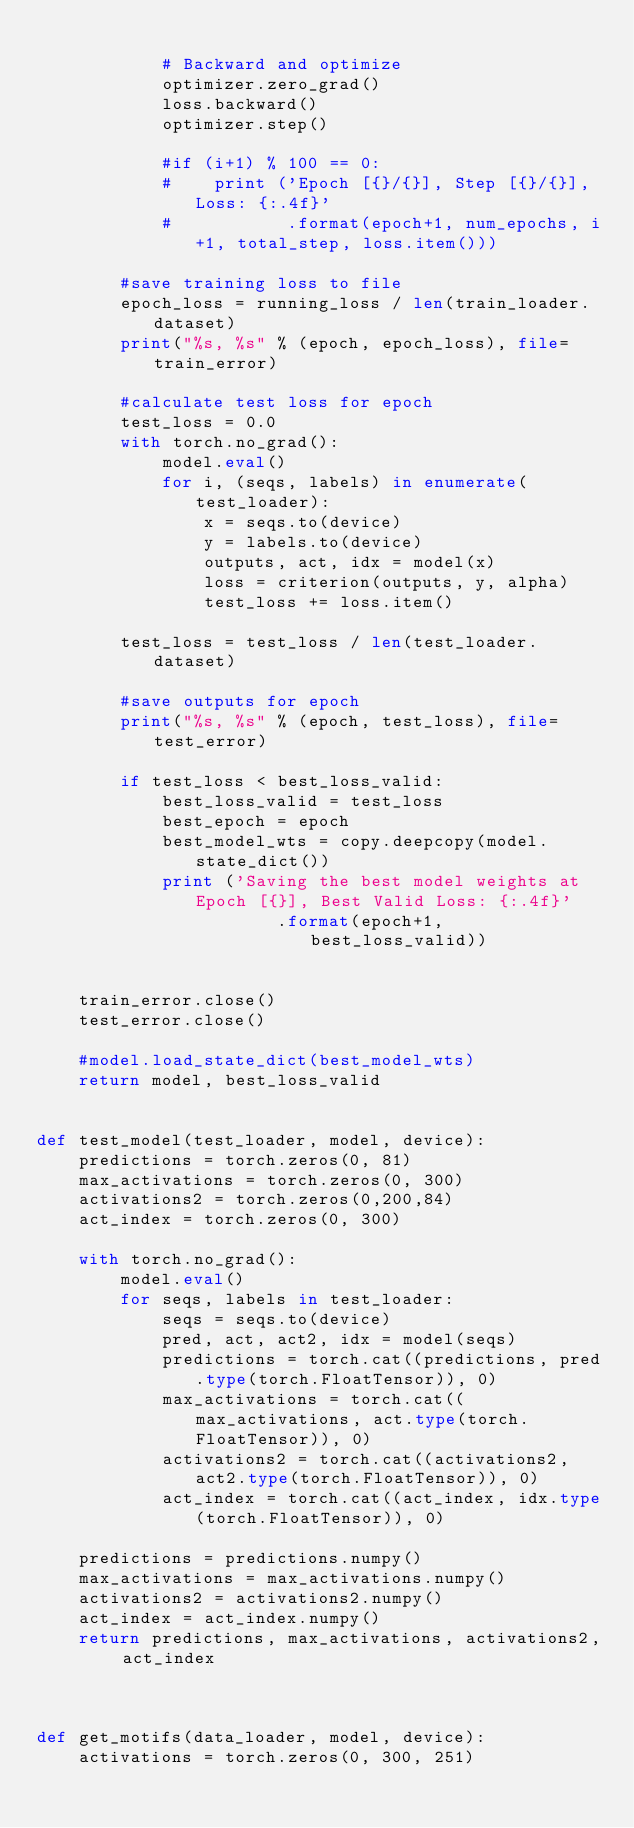<code> <loc_0><loc_0><loc_500><loc_500><_Python_>        
            # Backward and optimize
            optimizer.zero_grad()
            loss.backward()
            optimizer.step()

            #if (i+1) % 100 == 0:
            #    print ('Epoch [{}/{}], Step [{}/{}], Loss: {:.4f}'
            #           .format(epoch+1, num_epochs, i+1, total_step, loss.item()))

        #save training loss to file
        epoch_loss = running_loss / len(train_loader.dataset)
        print("%s, %s" % (epoch, epoch_loss), file=train_error)

        #calculate test loss for epoch
        test_loss = 0.0
        with torch.no_grad():
            model.eval()
            for i, (seqs, labels) in enumerate(test_loader):
                x = seqs.to(device)
                y = labels.to(device)
                outputs, act, idx = model(x)
                loss = criterion(outputs, y, alpha)
                test_loss += loss.item() 

        test_loss = test_loss / len(test_loader.dataset)

        #save outputs for epoch
        print("%s, %s" % (epoch, test_loss), file=test_error)

        if test_loss < best_loss_valid:
            best_loss_valid = test_loss
            best_epoch = epoch
            best_model_wts = copy.deepcopy(model.state_dict())
            print ('Saving the best model weights at Epoch [{}], Best Valid Loss: {:.4f}' 
                       .format(epoch+1, best_loss_valid))


    train_error.close()
    test_error.close()

    #model.load_state_dict(best_model_wts)
    return model, best_loss_valid
    

def test_model(test_loader, model, device):
    predictions = torch.zeros(0, 81)
    max_activations = torch.zeros(0, 300) 
    activations2 = torch.zeros(0,200,84)
    act_index = torch.zeros(0, 300)

    with torch.no_grad():
        model.eval()
        for seqs, labels in test_loader:
            seqs = seqs.to(device)
            pred, act, act2, idx = model(seqs)
            predictions = torch.cat((predictions, pred.type(torch.FloatTensor)), 0)
            max_activations = torch.cat((max_activations, act.type(torch.FloatTensor)), 0)
            activations2 = torch.cat((activations2, act2.type(torch.FloatTensor)), 0)
            act_index = torch.cat((act_index, idx.type(torch.FloatTensor)), 0)

    predictions = predictions.numpy()
    max_activations = max_activations.numpy()
    activations2 = activations2.numpy()
    act_index = act_index.numpy()
    return predictions, max_activations, activations2, act_index



def get_motifs(data_loader, model, device):
    activations = torch.zeros(0, 300, 251)</code> 